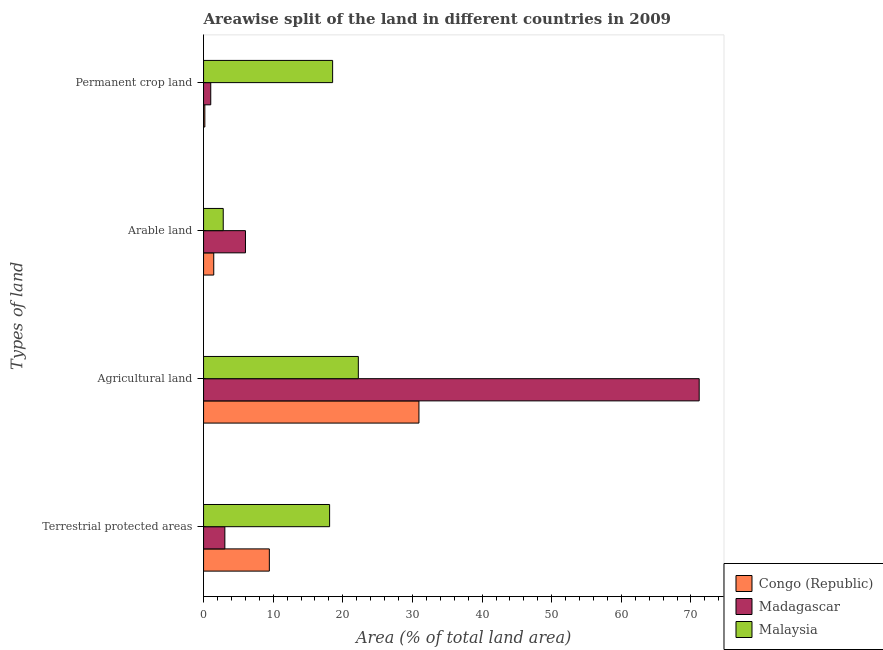How many groups of bars are there?
Make the answer very short. 4. Are the number of bars on each tick of the Y-axis equal?
Offer a very short reply. Yes. How many bars are there on the 1st tick from the bottom?
Your answer should be compact. 3. What is the label of the 3rd group of bars from the top?
Give a very brief answer. Agricultural land. What is the percentage of land under terrestrial protection in Madagascar?
Make the answer very short. 3.06. Across all countries, what is the maximum percentage of area under permanent crop land?
Your answer should be very brief. 18.54. Across all countries, what is the minimum percentage of area under agricultural land?
Provide a succinct answer. 22.23. In which country was the percentage of area under arable land maximum?
Offer a very short reply. Madagascar. In which country was the percentage of area under arable land minimum?
Your answer should be very brief. Congo (Republic). What is the total percentage of area under permanent crop land in the graph?
Provide a succinct answer. 19.75. What is the difference between the percentage of area under agricultural land in Malaysia and that in Madagascar?
Offer a terse response. -48.95. What is the difference between the percentage of area under agricultural land in Congo (Republic) and the percentage of area under permanent crop land in Malaysia?
Ensure brevity in your answer.  12.4. What is the average percentage of area under agricultural land per country?
Your response must be concise. 41.45. What is the difference between the percentage of area under arable land and percentage of area under permanent crop land in Congo (Republic)?
Make the answer very short. 1.28. What is the ratio of the percentage of area under arable land in Congo (Republic) to that in Malaysia?
Offer a very short reply. 0.52. Is the difference between the percentage of area under permanent crop land in Madagascar and Congo (Republic) greater than the difference between the percentage of area under agricultural land in Madagascar and Congo (Republic)?
Make the answer very short. No. What is the difference between the highest and the second highest percentage of area under agricultural land?
Make the answer very short. 40.25. What is the difference between the highest and the lowest percentage of area under arable land?
Offer a terse response. 4.55. In how many countries, is the percentage of area under agricultural land greater than the average percentage of area under agricultural land taken over all countries?
Give a very brief answer. 1. What does the 3rd bar from the top in Agricultural land represents?
Your response must be concise. Congo (Republic). What does the 1st bar from the bottom in Terrestrial protected areas represents?
Give a very brief answer. Congo (Republic). Is it the case that in every country, the sum of the percentage of land under terrestrial protection and percentage of area under agricultural land is greater than the percentage of area under arable land?
Offer a very short reply. Yes. How many countries are there in the graph?
Offer a terse response. 3. What is the difference between two consecutive major ticks on the X-axis?
Your answer should be very brief. 10. Does the graph contain any zero values?
Offer a terse response. No. Does the graph contain grids?
Your response must be concise. No. Where does the legend appear in the graph?
Your answer should be compact. Bottom right. What is the title of the graph?
Keep it short and to the point. Areawise split of the land in different countries in 2009. What is the label or title of the X-axis?
Keep it short and to the point. Area (% of total land area). What is the label or title of the Y-axis?
Offer a very short reply. Types of land. What is the Area (% of total land area) of Congo (Republic) in Terrestrial protected areas?
Provide a succinct answer. 9.45. What is the Area (% of total land area) of Madagascar in Terrestrial protected areas?
Your response must be concise. 3.06. What is the Area (% of total land area) of Malaysia in Terrestrial protected areas?
Offer a terse response. 18.1. What is the Area (% of total land area) of Congo (Republic) in Agricultural land?
Your response must be concise. 30.93. What is the Area (% of total land area) of Madagascar in Agricultural land?
Keep it short and to the point. 71.18. What is the Area (% of total land area) of Malaysia in Agricultural land?
Provide a succinct answer. 22.23. What is the Area (% of total land area) in Congo (Republic) in Arable land?
Provide a short and direct response. 1.46. What is the Area (% of total land area) of Madagascar in Arable land?
Provide a short and direct response. 6.02. What is the Area (% of total land area) in Malaysia in Arable land?
Offer a terse response. 2.82. What is the Area (% of total land area) of Congo (Republic) in Permanent crop land?
Your answer should be very brief. 0.18. What is the Area (% of total land area) of Madagascar in Permanent crop land?
Your response must be concise. 1.03. What is the Area (% of total land area) in Malaysia in Permanent crop land?
Keep it short and to the point. 18.54. Across all Types of land, what is the maximum Area (% of total land area) of Congo (Republic)?
Provide a short and direct response. 30.93. Across all Types of land, what is the maximum Area (% of total land area) in Madagascar?
Your answer should be very brief. 71.18. Across all Types of land, what is the maximum Area (% of total land area) in Malaysia?
Offer a very short reply. 22.23. Across all Types of land, what is the minimum Area (% of total land area) of Congo (Republic)?
Your answer should be very brief. 0.18. Across all Types of land, what is the minimum Area (% of total land area) in Madagascar?
Provide a short and direct response. 1.03. Across all Types of land, what is the minimum Area (% of total land area) in Malaysia?
Ensure brevity in your answer.  2.82. What is the total Area (% of total land area) of Congo (Republic) in the graph?
Your answer should be compact. 42.03. What is the total Area (% of total land area) in Madagascar in the graph?
Ensure brevity in your answer.  81.29. What is the total Area (% of total land area) of Malaysia in the graph?
Your answer should be compact. 61.69. What is the difference between the Area (% of total land area) in Congo (Republic) in Terrestrial protected areas and that in Agricultural land?
Offer a terse response. -21.48. What is the difference between the Area (% of total land area) in Madagascar in Terrestrial protected areas and that in Agricultural land?
Ensure brevity in your answer.  -68.12. What is the difference between the Area (% of total land area) of Malaysia in Terrestrial protected areas and that in Agricultural land?
Your answer should be compact. -4.13. What is the difference between the Area (% of total land area) in Congo (Republic) in Terrestrial protected areas and that in Arable land?
Provide a short and direct response. 7.98. What is the difference between the Area (% of total land area) in Madagascar in Terrestrial protected areas and that in Arable land?
Your response must be concise. -2.96. What is the difference between the Area (% of total land area) of Malaysia in Terrestrial protected areas and that in Arable land?
Your response must be concise. 15.28. What is the difference between the Area (% of total land area) in Congo (Republic) in Terrestrial protected areas and that in Permanent crop land?
Give a very brief answer. 9.26. What is the difference between the Area (% of total land area) of Madagascar in Terrestrial protected areas and that in Permanent crop land?
Ensure brevity in your answer.  2.03. What is the difference between the Area (% of total land area) of Malaysia in Terrestrial protected areas and that in Permanent crop land?
Offer a very short reply. -0.43. What is the difference between the Area (% of total land area) of Congo (Republic) in Agricultural land and that in Arable land?
Provide a short and direct response. 29.47. What is the difference between the Area (% of total land area) in Madagascar in Agricultural land and that in Arable land?
Give a very brief answer. 65.16. What is the difference between the Area (% of total land area) in Malaysia in Agricultural land and that in Arable land?
Your response must be concise. 19.4. What is the difference between the Area (% of total land area) in Congo (Republic) in Agricultural land and that in Permanent crop land?
Your answer should be compact. 30.75. What is the difference between the Area (% of total land area) in Madagascar in Agricultural land and that in Permanent crop land?
Keep it short and to the point. 70.15. What is the difference between the Area (% of total land area) in Malaysia in Agricultural land and that in Permanent crop land?
Offer a terse response. 3.69. What is the difference between the Area (% of total land area) in Congo (Republic) in Arable land and that in Permanent crop land?
Ensure brevity in your answer.  1.28. What is the difference between the Area (% of total land area) of Madagascar in Arable land and that in Permanent crop land?
Provide a short and direct response. 4.99. What is the difference between the Area (% of total land area) of Malaysia in Arable land and that in Permanent crop land?
Offer a very short reply. -15.71. What is the difference between the Area (% of total land area) in Congo (Republic) in Terrestrial protected areas and the Area (% of total land area) in Madagascar in Agricultural land?
Ensure brevity in your answer.  -61.73. What is the difference between the Area (% of total land area) in Congo (Republic) in Terrestrial protected areas and the Area (% of total land area) in Malaysia in Agricultural land?
Give a very brief answer. -12.78. What is the difference between the Area (% of total land area) in Madagascar in Terrestrial protected areas and the Area (% of total land area) in Malaysia in Agricultural land?
Offer a terse response. -19.17. What is the difference between the Area (% of total land area) of Congo (Republic) in Terrestrial protected areas and the Area (% of total land area) of Madagascar in Arable land?
Your answer should be very brief. 3.43. What is the difference between the Area (% of total land area) of Congo (Republic) in Terrestrial protected areas and the Area (% of total land area) of Malaysia in Arable land?
Provide a succinct answer. 6.62. What is the difference between the Area (% of total land area) of Madagascar in Terrestrial protected areas and the Area (% of total land area) of Malaysia in Arable land?
Provide a succinct answer. 0.23. What is the difference between the Area (% of total land area) of Congo (Republic) in Terrestrial protected areas and the Area (% of total land area) of Madagascar in Permanent crop land?
Provide a short and direct response. 8.42. What is the difference between the Area (% of total land area) of Congo (Republic) in Terrestrial protected areas and the Area (% of total land area) of Malaysia in Permanent crop land?
Offer a terse response. -9.09. What is the difference between the Area (% of total land area) of Madagascar in Terrestrial protected areas and the Area (% of total land area) of Malaysia in Permanent crop land?
Ensure brevity in your answer.  -15.48. What is the difference between the Area (% of total land area) of Congo (Republic) in Agricultural land and the Area (% of total land area) of Madagascar in Arable land?
Provide a succinct answer. 24.91. What is the difference between the Area (% of total land area) in Congo (Republic) in Agricultural land and the Area (% of total land area) in Malaysia in Arable land?
Provide a short and direct response. 28.11. What is the difference between the Area (% of total land area) of Madagascar in Agricultural land and the Area (% of total land area) of Malaysia in Arable land?
Offer a terse response. 68.36. What is the difference between the Area (% of total land area) in Congo (Republic) in Agricultural land and the Area (% of total land area) in Madagascar in Permanent crop land?
Give a very brief answer. 29.9. What is the difference between the Area (% of total land area) in Congo (Republic) in Agricultural land and the Area (% of total land area) in Malaysia in Permanent crop land?
Your response must be concise. 12.4. What is the difference between the Area (% of total land area) in Madagascar in Agricultural land and the Area (% of total land area) in Malaysia in Permanent crop land?
Your answer should be compact. 52.65. What is the difference between the Area (% of total land area) of Congo (Republic) in Arable land and the Area (% of total land area) of Madagascar in Permanent crop land?
Offer a terse response. 0.43. What is the difference between the Area (% of total land area) in Congo (Republic) in Arable land and the Area (% of total land area) in Malaysia in Permanent crop land?
Your answer should be compact. -17.07. What is the difference between the Area (% of total land area) of Madagascar in Arable land and the Area (% of total land area) of Malaysia in Permanent crop land?
Make the answer very short. -12.52. What is the average Area (% of total land area) of Congo (Republic) per Types of land?
Provide a succinct answer. 10.51. What is the average Area (% of total land area) of Madagascar per Types of land?
Keep it short and to the point. 20.32. What is the average Area (% of total land area) in Malaysia per Types of land?
Ensure brevity in your answer.  15.42. What is the difference between the Area (% of total land area) in Congo (Republic) and Area (% of total land area) in Madagascar in Terrestrial protected areas?
Offer a terse response. 6.39. What is the difference between the Area (% of total land area) in Congo (Republic) and Area (% of total land area) in Malaysia in Terrestrial protected areas?
Make the answer very short. -8.65. What is the difference between the Area (% of total land area) in Madagascar and Area (% of total land area) in Malaysia in Terrestrial protected areas?
Offer a terse response. -15.04. What is the difference between the Area (% of total land area) in Congo (Republic) and Area (% of total land area) in Madagascar in Agricultural land?
Your answer should be compact. -40.25. What is the difference between the Area (% of total land area) in Congo (Republic) and Area (% of total land area) in Malaysia in Agricultural land?
Provide a succinct answer. 8.7. What is the difference between the Area (% of total land area) in Madagascar and Area (% of total land area) in Malaysia in Agricultural land?
Ensure brevity in your answer.  48.95. What is the difference between the Area (% of total land area) in Congo (Republic) and Area (% of total land area) in Madagascar in Arable land?
Provide a short and direct response. -4.55. What is the difference between the Area (% of total land area) of Congo (Republic) and Area (% of total land area) of Malaysia in Arable land?
Give a very brief answer. -1.36. What is the difference between the Area (% of total land area) of Madagascar and Area (% of total land area) of Malaysia in Arable land?
Your answer should be compact. 3.19. What is the difference between the Area (% of total land area) in Congo (Republic) and Area (% of total land area) in Madagascar in Permanent crop land?
Offer a very short reply. -0.85. What is the difference between the Area (% of total land area) in Congo (Republic) and Area (% of total land area) in Malaysia in Permanent crop land?
Make the answer very short. -18.35. What is the difference between the Area (% of total land area) of Madagascar and Area (% of total land area) of Malaysia in Permanent crop land?
Provide a succinct answer. -17.5. What is the ratio of the Area (% of total land area) in Congo (Republic) in Terrestrial protected areas to that in Agricultural land?
Your response must be concise. 0.31. What is the ratio of the Area (% of total land area) of Madagascar in Terrestrial protected areas to that in Agricultural land?
Your response must be concise. 0.04. What is the ratio of the Area (% of total land area) in Malaysia in Terrestrial protected areas to that in Agricultural land?
Offer a terse response. 0.81. What is the ratio of the Area (% of total land area) in Congo (Republic) in Terrestrial protected areas to that in Arable land?
Keep it short and to the point. 6.45. What is the ratio of the Area (% of total land area) in Madagascar in Terrestrial protected areas to that in Arable land?
Your answer should be compact. 0.51. What is the ratio of the Area (% of total land area) in Malaysia in Terrestrial protected areas to that in Arable land?
Give a very brief answer. 6.41. What is the ratio of the Area (% of total land area) in Congo (Republic) in Terrestrial protected areas to that in Permanent crop land?
Offer a very short reply. 51.21. What is the ratio of the Area (% of total land area) in Madagascar in Terrestrial protected areas to that in Permanent crop land?
Offer a terse response. 2.96. What is the ratio of the Area (% of total land area) in Malaysia in Terrestrial protected areas to that in Permanent crop land?
Provide a short and direct response. 0.98. What is the ratio of the Area (% of total land area) of Congo (Republic) in Agricultural land to that in Arable land?
Your answer should be compact. 21.13. What is the ratio of the Area (% of total land area) of Madagascar in Agricultural land to that in Arable land?
Your answer should be very brief. 11.83. What is the ratio of the Area (% of total land area) of Malaysia in Agricultural land to that in Arable land?
Make the answer very short. 7.87. What is the ratio of the Area (% of total land area) of Congo (Republic) in Agricultural land to that in Permanent crop land?
Provide a short and direct response. 167.67. What is the ratio of the Area (% of total land area) of Madagascar in Agricultural land to that in Permanent crop land?
Provide a succinct answer. 68.99. What is the ratio of the Area (% of total land area) in Malaysia in Agricultural land to that in Permanent crop land?
Ensure brevity in your answer.  1.2. What is the ratio of the Area (% of total land area) in Congo (Republic) in Arable land to that in Permanent crop land?
Your answer should be compact. 7.94. What is the ratio of the Area (% of total land area) of Madagascar in Arable land to that in Permanent crop land?
Ensure brevity in your answer.  5.83. What is the ratio of the Area (% of total land area) in Malaysia in Arable land to that in Permanent crop land?
Your answer should be very brief. 0.15. What is the difference between the highest and the second highest Area (% of total land area) of Congo (Republic)?
Give a very brief answer. 21.48. What is the difference between the highest and the second highest Area (% of total land area) in Madagascar?
Ensure brevity in your answer.  65.16. What is the difference between the highest and the second highest Area (% of total land area) of Malaysia?
Keep it short and to the point. 3.69. What is the difference between the highest and the lowest Area (% of total land area) of Congo (Republic)?
Provide a short and direct response. 30.75. What is the difference between the highest and the lowest Area (% of total land area) in Madagascar?
Your response must be concise. 70.15. What is the difference between the highest and the lowest Area (% of total land area) of Malaysia?
Ensure brevity in your answer.  19.4. 